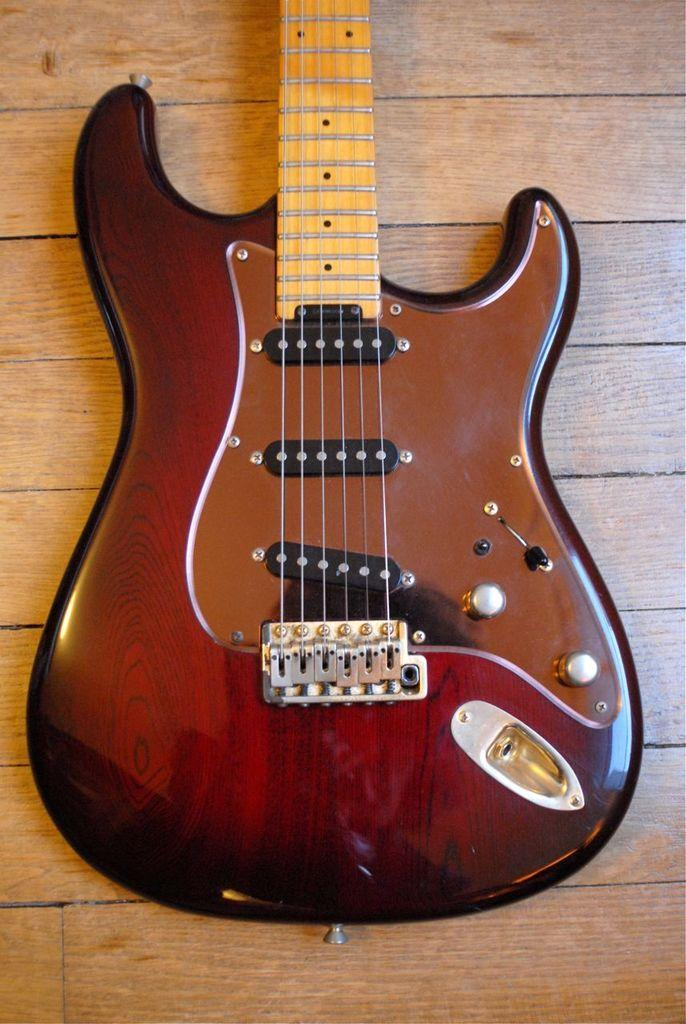What musical instrument is present in the image? There is a guitar in the image. How many strings does the guitar have? The guitar has six strings. What is the color of the guitar? The guitar is brown in color. Where is the guitar placed in the image? The guitar is placed on a table. Can you tell me how many cactus plants are growing under the guitar in the image? There are no cactus plants present in the image, and the guitar is not placed on any plants. 